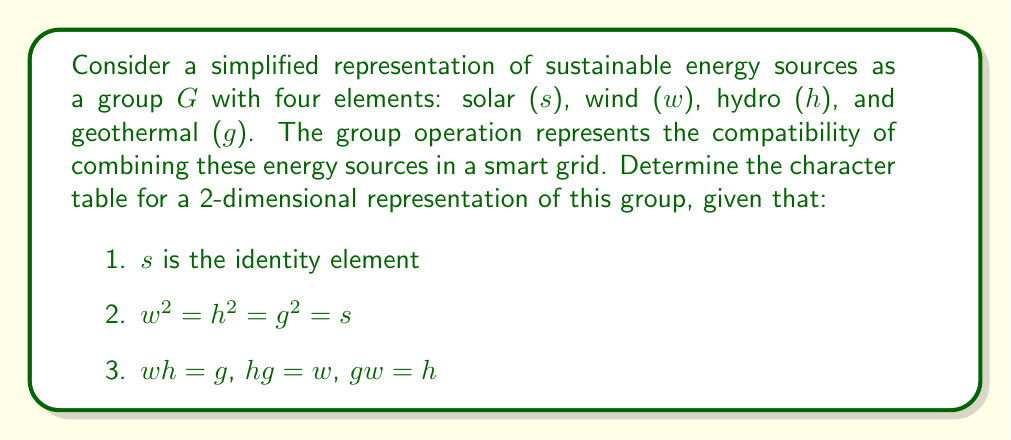Could you help me with this problem? To determine the character table, we'll follow these steps:

1. Identify the conjugacy classes:
   - $\{s\}$: identity
   - $\{w, h, g\}$: all other elements are conjugate to each other

2. Determine the irreducible representations:
   - Number of irreducible representations = number of conjugacy classes = 2
   - Dimensions: $1^2 + 1^2 + 2^2 = 6$ (order of the group)
   - So, we have two 1-dimensional representations and one 2-dimensional representation

3. Construct the character table:
   Let $\chi_1$, $\chi_2$ be the 1-dimensional representations, and $\chi_3$ be the 2-dimensional representation.

   $$\begin{array}{c|cc}
   G & \{s\} & \{w,h,g\} \\
   \hline
   \chi_1 & 1 & 1 \\
   \chi_2 & 1 & -1 \\
   \chi_3 & 2 & 0
   \end{array}$$

4. Verify orthogonality relations:
   - $\langle \chi_i, \chi_j \rangle = \frac{1}{|G|} \sum_{g \in G} \chi_i(g) \overline{\chi_j(g)} = \delta_{ij}$
   - $\sum_i |\chi_i(g)|^2 = |C_G(g)|$, where $C_G(g)$ is the centralizer of $g$

5. For the 2-dimensional representation $\chi_3$:
   - $\chi_3(s) = 2$ (trace of identity matrix)
   - $\chi_3(w) = \chi_3(h) = \chi_3(g) = 0$ (trace of a 2x2 matrix with eigenvalues $i$ and $-i$)

This character table is consistent with the given group structure and satisfies the required properties of character tables.
Answer: $$\begin{array}{c|cc}
G & \{s\} & \{w,h,g\} \\
\hline
\chi_1 & 1 & 1 \\
\chi_2 & 1 & -1 \\
\chi_3 & 2 & 0
\end{array}$$ 